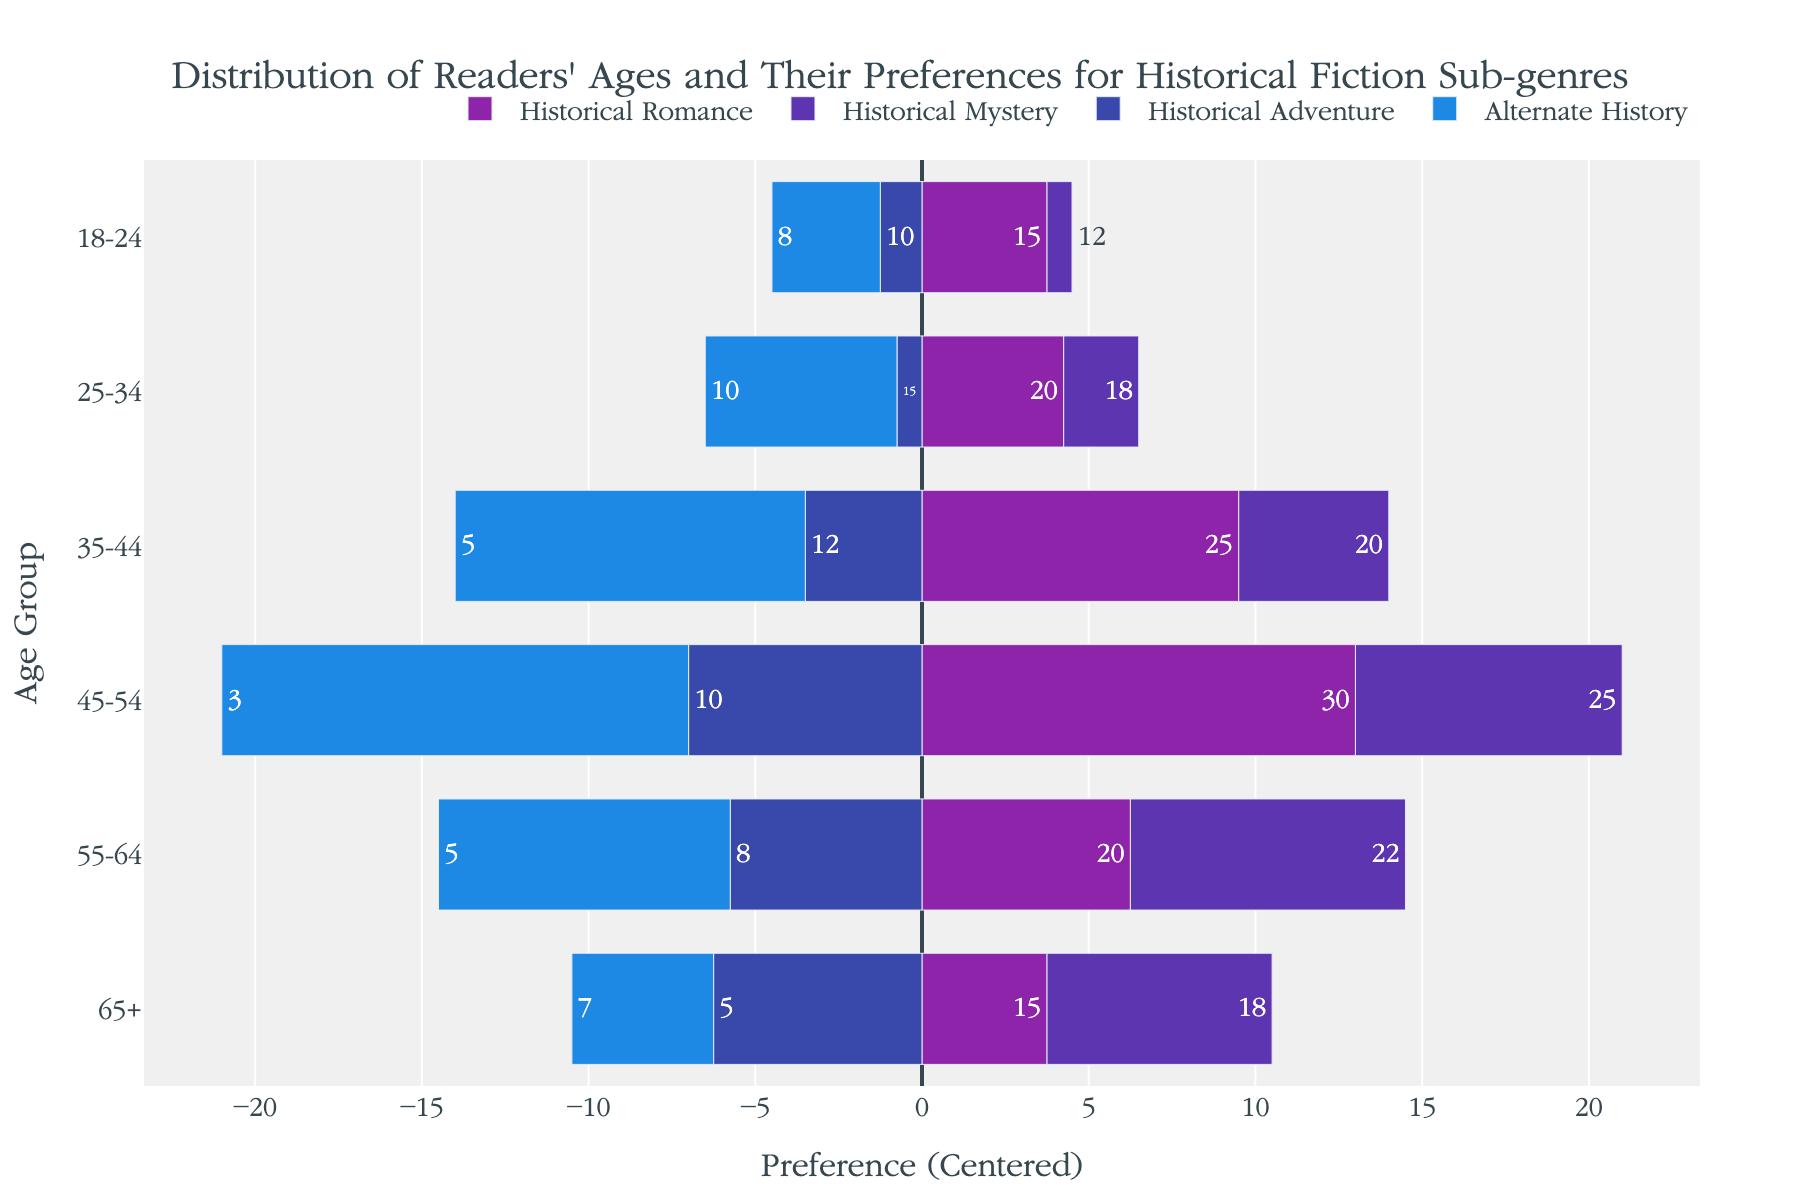What age group has the highest preference for Historical Romance? By looking at the diverging bar chart, the longest bar under the 'Historical Romance' sub-genre will show the age group with the highest preference.
Answer: 45-54 Which sub-genre is most preferred by the 25-34 age group? By examining the bars for the 25-34 age group, the longest bar in the 'Historical Romance' sub-genre indicates the highest preference.
Answer: Historical Romance How does the preference for Historical Mystery change as age increases from 18-24 to 55-64? As age increases, look at the 'Historical Mystery' bars for each age group from 18-24 to 55-64. Preferences increase overall, with a peak in the 55-64 age group.
Answer: Increases, peaking at 55-64 What is the combined preference for Historical Romance and Historical Adventure among the 35-44 age group? Look at the preference values for 'Historical Romance' (25) and 'Historical Adventure' (12) in the 35-44 age group, then add them together: 25 + 12 = 37.
Answer: 37 Which age group has the smallest preference for Alternate History? By examining the shortest bar under the 'Alternate History' sub-genre, the 45-54 age group has the smallest preference with a value of 3.
Answer: 45-54 Is the preference for Historical Romance higher or lower than Historical Adventure in the 65+ age group? Compare the length of the bars for 'Historical Romance' (15) and 'Historical Adventure' (5) in the 65+ age group. 'Historical Romance' has a higher preference.
Answer: Higher Which sub-genre shows a declining trend in preference as age increases from 18-24 to 45-54? By analyzing the bars for each sub-genre as age increases, 'Historical Adventure' consistently decreases from 18-24 to 45-54.
Answer: Historical Adventure What is the average preference across all sub-genres for the 45-54 age group? Sum the values across all sub-genres for 45-54: 30 (Romance) + 25 (Mystery) + 10 (Adventure) + 3 (Alternate) = 68, then divide by 4: 68/4 = 17.
Answer: 17 How does the preference for Alternate History compare between 18-24 and 65+ age groups? Compare the values of 'Alternate History' for the 18-24 (8) and 65+ (7) age groups. The preference is slightly higher for 18-24.
Answer: Slightly higher for 18-24 